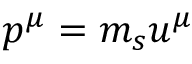<formula> <loc_0><loc_0><loc_500><loc_500>p ^ { \mu } = m _ { s } u ^ { \mu }</formula> 